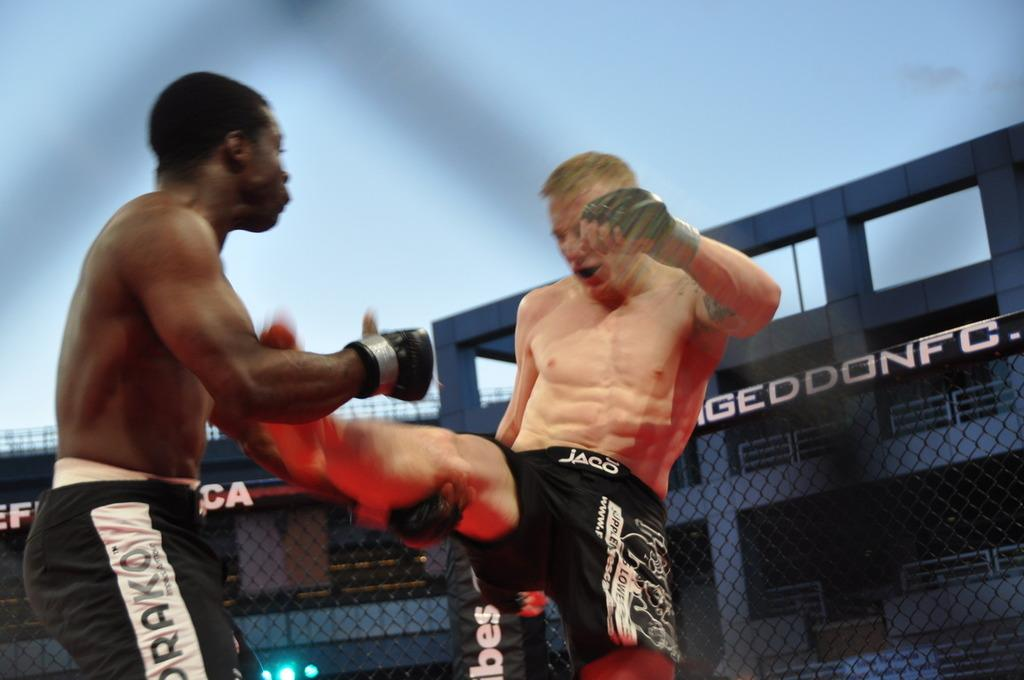<image>
Write a terse but informative summary of the picture. Two fighters in a ring, one of them is wearing Jaco Shorts. 